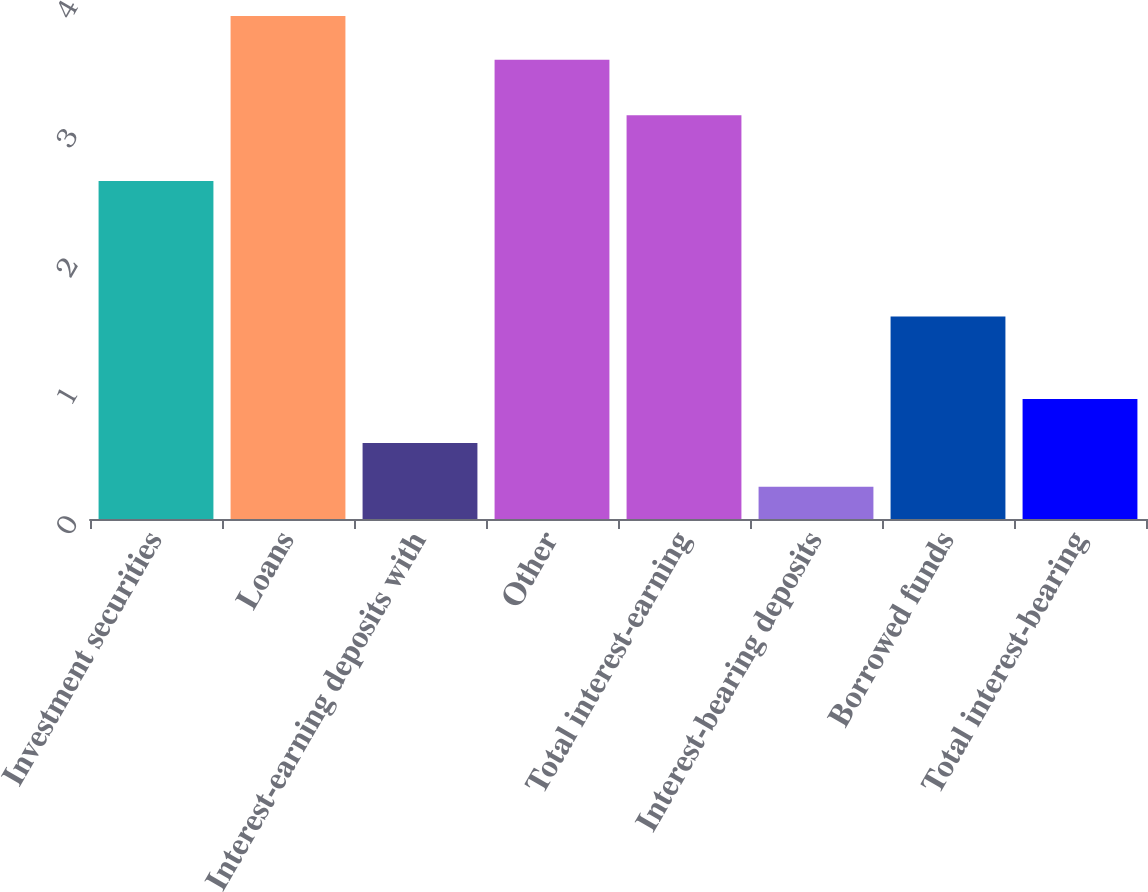<chart> <loc_0><loc_0><loc_500><loc_500><bar_chart><fcel>Investment securities<fcel>Loans<fcel>Interest-earning deposits with<fcel>Other<fcel>Total interest-earning<fcel>Interest-bearing deposits<fcel>Borrowed funds<fcel>Total interest-bearing<nl><fcel>2.62<fcel>3.9<fcel>0.59<fcel>3.56<fcel>3.13<fcel>0.25<fcel>1.57<fcel>0.93<nl></chart> 